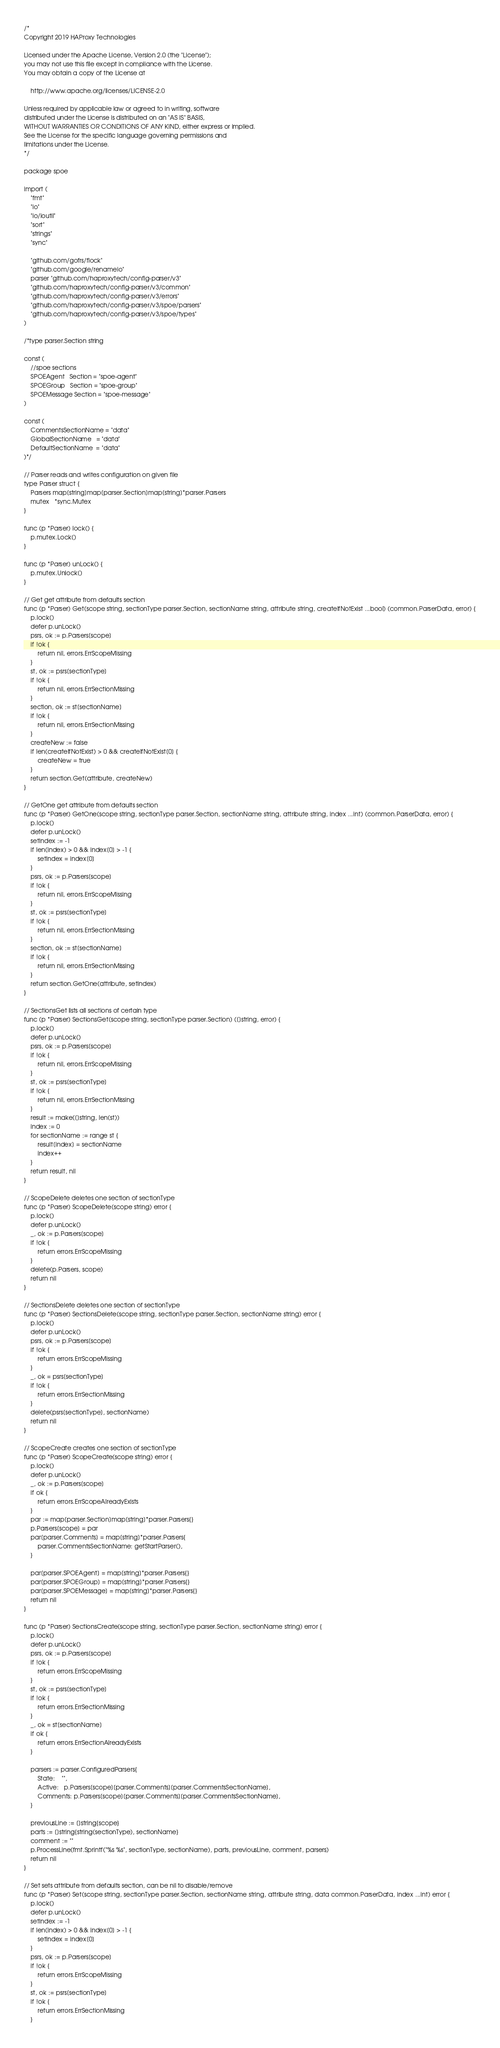Convert code to text. <code><loc_0><loc_0><loc_500><loc_500><_Go_>/*
Copyright 2019 HAProxy Technologies

Licensed under the Apache License, Version 2.0 (the "License");
you may not use this file except in compliance with the License.
You may obtain a copy of the License at

    http://www.apache.org/licenses/LICENSE-2.0

Unless required by applicable law or agreed to in writing, software
distributed under the License is distributed on an "AS IS" BASIS,
WITHOUT WARRANTIES OR CONDITIONS OF ANY KIND, either express or implied.
See the License for the specific language governing permissions and
limitations under the License.
*/

package spoe

import (
	"fmt"
	"io"
	"io/ioutil"
	"sort"
	"strings"
	"sync"

	"github.com/gofrs/flock"
	"github.com/google/renameio"
	parser "github.com/haproxytech/config-parser/v3"
	"github.com/haproxytech/config-parser/v3/common"
	"github.com/haproxytech/config-parser/v3/errors"
	"github.com/haproxytech/config-parser/v3/spoe/parsers"
	"github.com/haproxytech/config-parser/v3/spoe/types"
)

/*type parser.Section string

const (
	//spoe sections
	SPOEAgent   Section = "spoe-agent"
	SPOEGroup   Section = "spoe-group"
	SPOEMessage Section = "spoe-message"
)

const (
	CommentsSectionName = "data"
	GlobalSectionName   = "data"
	DefaultSectionName  = "data"
)*/

// Parser reads and writes configuration on given file
type Parser struct {
	Parsers map[string]map[parser.Section]map[string]*parser.Parsers
	mutex   *sync.Mutex
}

func (p *Parser) lock() {
	p.mutex.Lock()
}

func (p *Parser) unLock() {
	p.mutex.Unlock()
}

// Get get attribute from defaults section
func (p *Parser) Get(scope string, sectionType parser.Section, sectionName string, attribute string, createIfNotExist ...bool) (common.ParserData, error) {
	p.lock()
	defer p.unLock()
	psrs, ok := p.Parsers[scope]
	if !ok {
		return nil, errors.ErrScopeMissing
	}
	st, ok := psrs[sectionType]
	if !ok {
		return nil, errors.ErrSectionMissing
	}
	section, ok := st[sectionName]
	if !ok {
		return nil, errors.ErrSectionMissing
	}
	createNew := false
	if len(createIfNotExist) > 0 && createIfNotExist[0] {
		createNew = true
	}
	return section.Get(attribute, createNew)
}

// GetOne get attribute from defaults section
func (p *Parser) GetOne(scope string, sectionType parser.Section, sectionName string, attribute string, index ...int) (common.ParserData, error) {
	p.lock()
	defer p.unLock()
	setIndex := -1
	if len(index) > 0 && index[0] > -1 {
		setIndex = index[0]
	}
	psrs, ok := p.Parsers[scope]
	if !ok {
		return nil, errors.ErrScopeMissing
	}
	st, ok := psrs[sectionType]
	if !ok {
		return nil, errors.ErrSectionMissing
	}
	section, ok := st[sectionName]
	if !ok {
		return nil, errors.ErrSectionMissing
	}
	return section.GetOne(attribute, setIndex)
}

// SectionsGet lists all sections of certain type
func (p *Parser) SectionsGet(scope string, sectionType parser.Section) ([]string, error) {
	p.lock()
	defer p.unLock()
	psrs, ok := p.Parsers[scope]
	if !ok {
		return nil, errors.ErrScopeMissing
	}
	st, ok := psrs[sectionType]
	if !ok {
		return nil, errors.ErrSectionMissing
	}
	result := make([]string, len(st))
	index := 0
	for sectionName := range st {
		result[index] = sectionName
		index++
	}
	return result, nil
}

// ScopeDelete deletes one section of sectionType
func (p *Parser) ScopeDelete(scope string) error {
	p.lock()
	defer p.unLock()
	_, ok := p.Parsers[scope]
	if !ok {
		return errors.ErrScopeMissing
	}
	delete(p.Parsers, scope)
	return nil
}

// SectionsDelete deletes one section of sectionType
func (p *Parser) SectionsDelete(scope string, sectionType parser.Section, sectionName string) error {
	p.lock()
	defer p.unLock()
	psrs, ok := p.Parsers[scope]
	if !ok {
		return errors.ErrScopeMissing
	}
	_, ok = psrs[sectionType]
	if !ok {
		return errors.ErrSectionMissing
	}
	delete(psrs[sectionType], sectionName)
	return nil
}

// ScopeCreate creates one section of sectionType
func (p *Parser) ScopeCreate(scope string) error {
	p.lock()
	defer p.unLock()
	_, ok := p.Parsers[scope]
	if ok {
		return errors.ErrScopeAlreadyExists
	}
	par := map[parser.Section]map[string]*parser.Parsers{}
	p.Parsers[scope] = par
	par[parser.Comments] = map[string]*parser.Parsers{
		parser.CommentsSectionName: getStartParser(),
	}

	par[parser.SPOEAgent] = map[string]*parser.Parsers{}
	par[parser.SPOEGroup] = map[string]*parser.Parsers{}
	par[parser.SPOEMessage] = map[string]*parser.Parsers{}
	return nil
}

func (p *Parser) SectionsCreate(scope string, sectionType parser.Section, sectionName string) error {
	p.lock()
	defer p.unLock()
	psrs, ok := p.Parsers[scope]
	if !ok {
		return errors.ErrScopeMissing
	}
	st, ok := psrs[sectionType]
	if !ok {
		return errors.ErrSectionMissing
	}
	_, ok = st[sectionName]
	if ok {
		return errors.ErrSectionAlreadyExists
	}

	parsers := parser.ConfiguredParsers{
		State:    "",
		Active:   p.Parsers[scope][parser.Comments][parser.CommentsSectionName],
		Comments: p.Parsers[scope][parser.Comments][parser.CommentsSectionName],
	}

	previousLine := []string{scope}
	parts := []string{string(sectionType), sectionName}
	comment := ""
	p.ProcessLine(fmt.Sprintf("%s %s", sectionType, sectionName), parts, previousLine, comment, parsers)
	return nil
}

// Set sets attribute from defaults section, can be nil to disable/remove
func (p *Parser) Set(scope string, sectionType parser.Section, sectionName string, attribute string, data common.ParserData, index ...int) error {
	p.lock()
	defer p.unLock()
	setIndex := -1
	if len(index) > 0 && index[0] > -1 {
		setIndex = index[0]
	}
	psrs, ok := p.Parsers[scope]
	if !ok {
		return errors.ErrScopeMissing
	}
	st, ok := psrs[sectionType]
	if !ok {
		return errors.ErrSectionMissing
	}</code> 